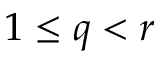Convert formula to latex. <formula><loc_0><loc_0><loc_500><loc_500>1 \leq q < r</formula> 